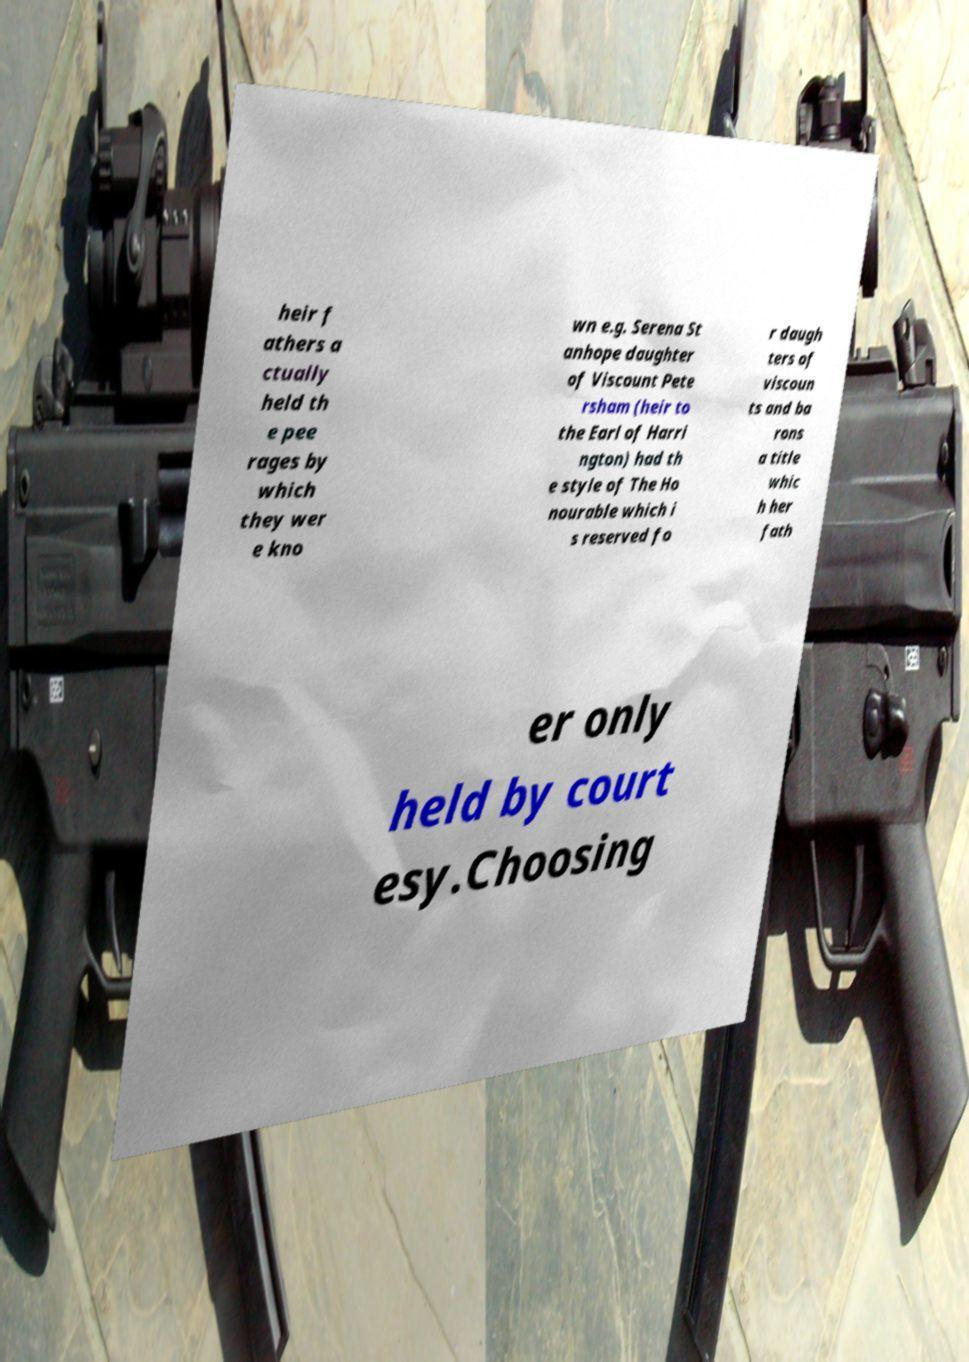I need the written content from this picture converted into text. Can you do that? heir f athers a ctually held th e pee rages by which they wer e kno wn e.g. Serena St anhope daughter of Viscount Pete rsham (heir to the Earl of Harri ngton) had th e style of The Ho nourable which i s reserved fo r daugh ters of viscoun ts and ba rons a title whic h her fath er only held by court esy.Choosing 